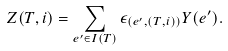Convert formula to latex. <formula><loc_0><loc_0><loc_500><loc_500>Z ( T , i ) = \sum _ { e ^ { \prime } \in I ( T ) } \epsilon _ { ( e ^ { \prime } , ( T , i ) ) } Y ( e ^ { \prime } ) .</formula> 